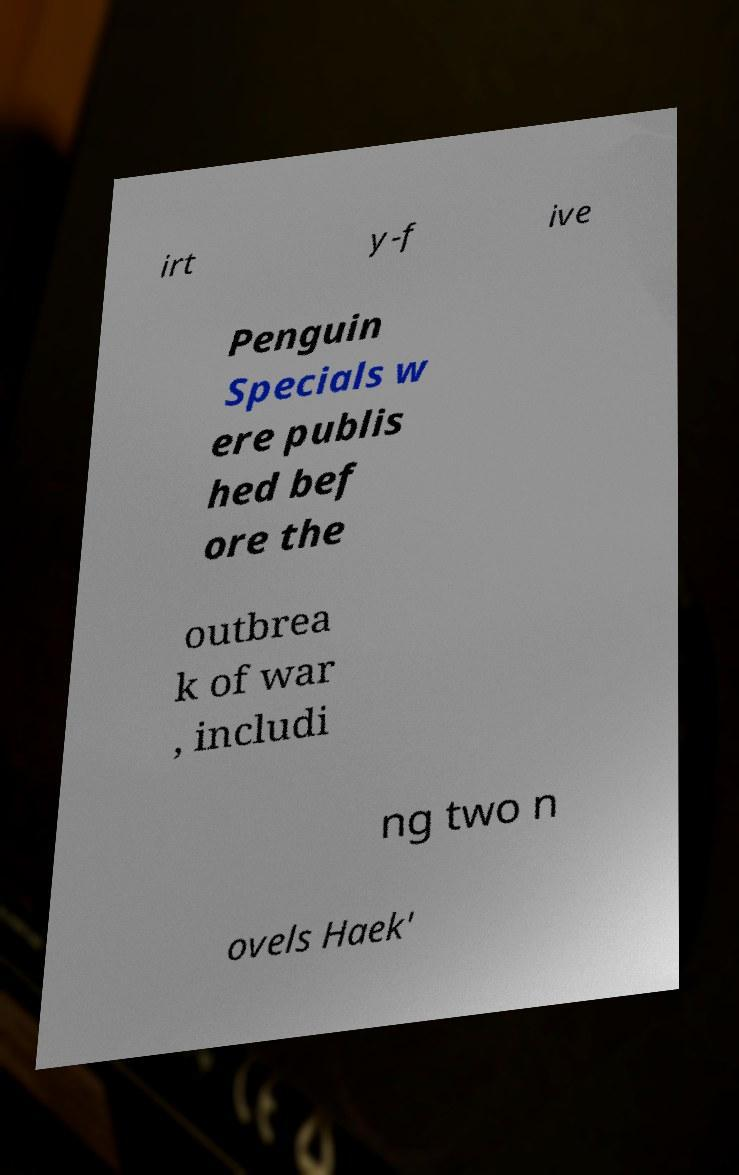Please read and relay the text visible in this image. What does it say? irt y-f ive Penguin Specials w ere publis hed bef ore the outbrea k of war , includi ng two n ovels Haek' 